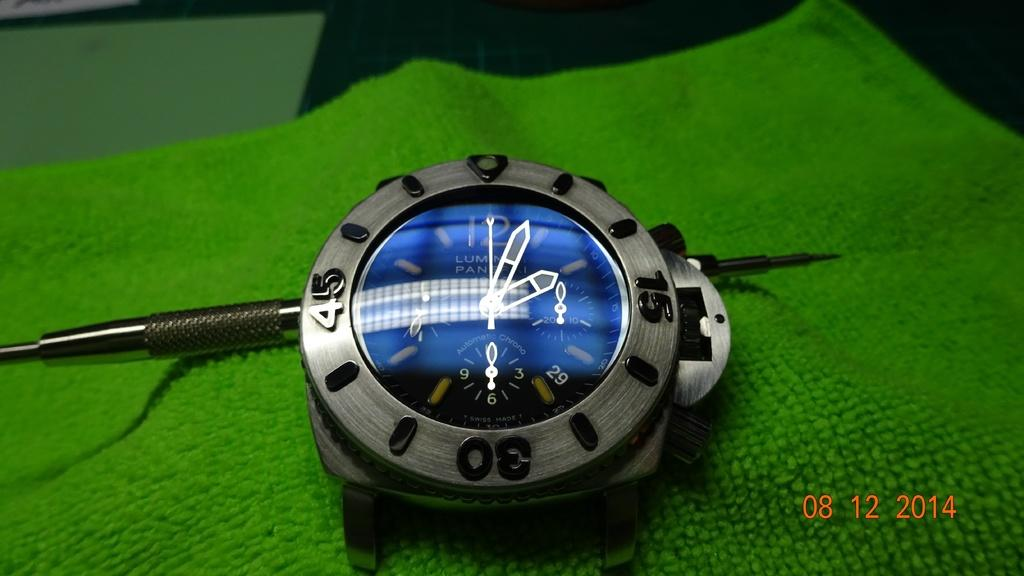<image>
Give a short and clear explanation of the subsequent image. A watch is on a green cloth and the image has the date 08 12 2014 at the bottom. 